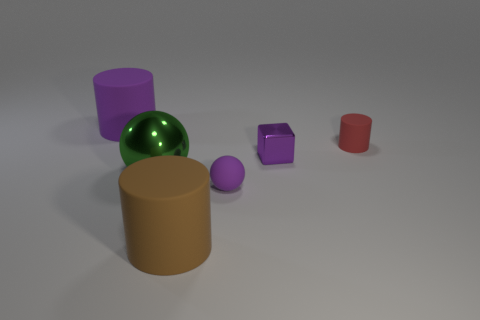Are there any blocks that have the same size as the red matte cylinder?
Your answer should be compact. Yes. What number of objects are either large rubber cylinders behind the tiny ball or big purple matte cylinders?
Keep it short and to the point. 1. Are the tiny purple block and the big cylinder that is on the left side of the brown object made of the same material?
Provide a succinct answer. No. What number of other things are there of the same shape as the tiny red thing?
Give a very brief answer. 2. What number of things are small matte objects in front of the purple metal cube or large green balls that are behind the small purple matte thing?
Make the answer very short. 2. What number of other things are the same color as the tiny metallic cube?
Make the answer very short. 2. Is the number of small metallic blocks that are in front of the purple block less than the number of purple matte objects right of the large metal object?
Your response must be concise. Yes. How many cylinders are there?
Your response must be concise. 3. Are there any other things that are made of the same material as the red object?
Give a very brief answer. Yes. What is the material of the other big object that is the same shape as the large purple thing?
Your answer should be compact. Rubber. 